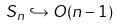Convert formula to latex. <formula><loc_0><loc_0><loc_500><loc_500>S _ { n } \hookrightarrow O ( n - 1 )</formula> 